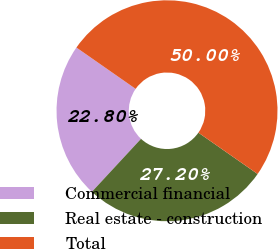Convert chart. <chart><loc_0><loc_0><loc_500><loc_500><pie_chart><fcel>Commercial financial<fcel>Real estate - construction<fcel>Total<nl><fcel>22.8%<fcel>27.2%<fcel>50.0%<nl></chart> 